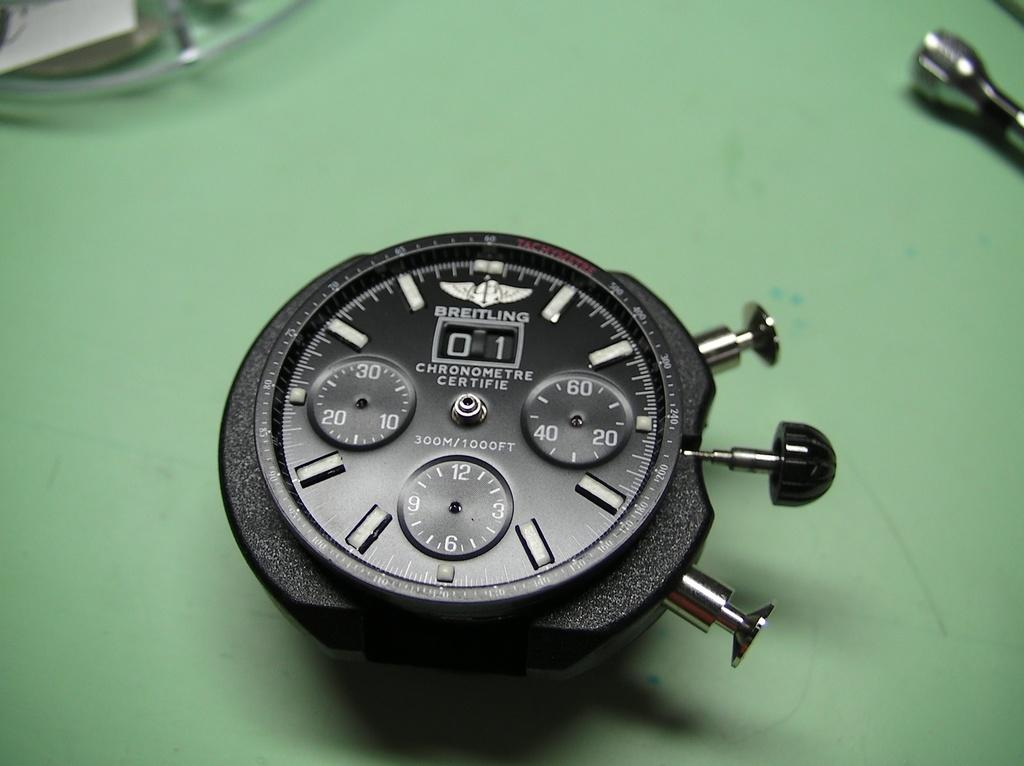<image>
Present a compact description of the photo's key features. A Breitling watch face contains three small dials and a date indicator. 